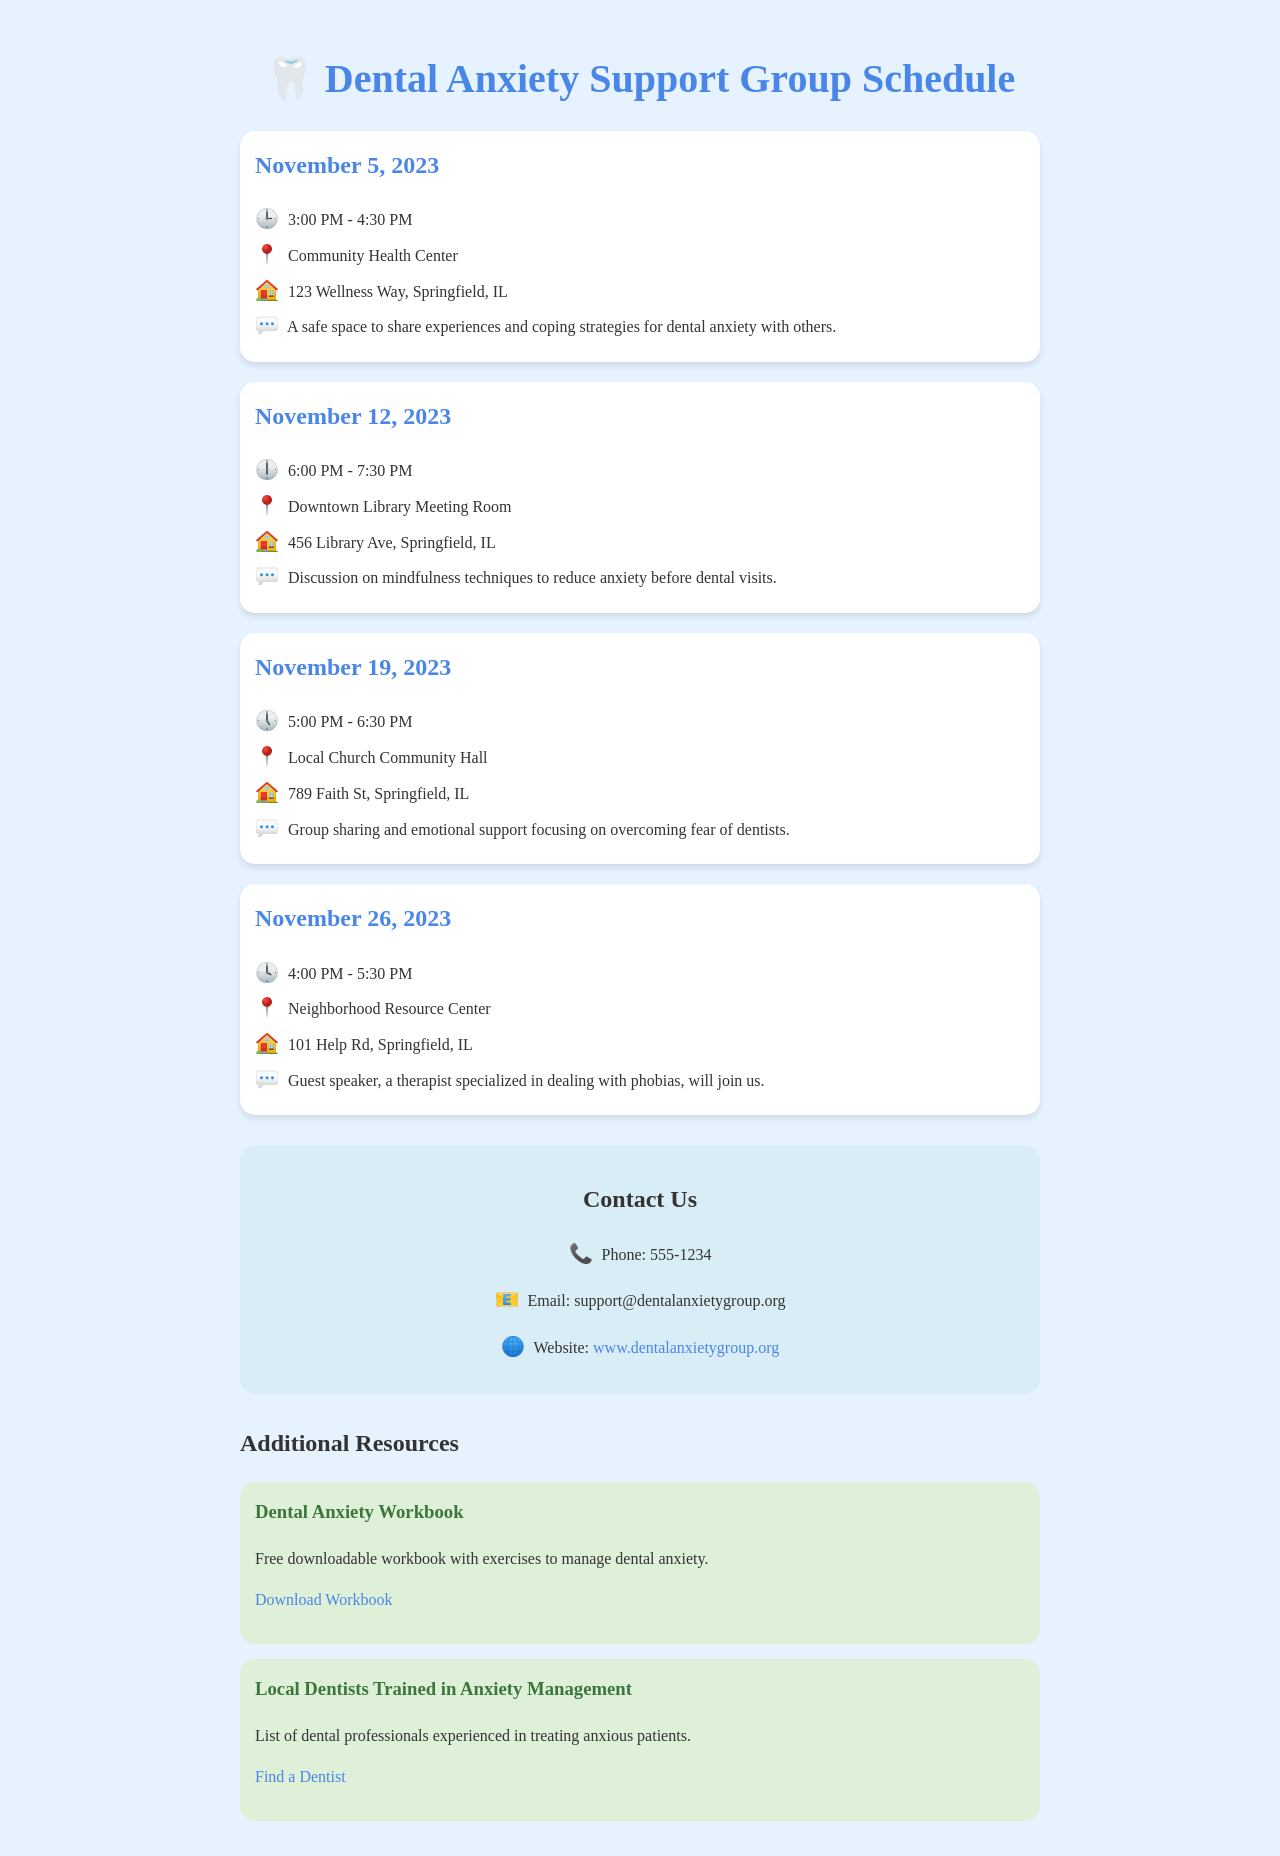What is the date of the first meeting? The first meeting listed in the document is on November 5, 2023.
Answer: November 5, 2023 Where is the second support group meeting held? The second meeting is held at the Downtown Library Meeting Room.
Answer: Downtown Library Meeting Room What is the time of the meeting on November 19, 2023? The meeting on November 19, 2023, is from 5:00 PM to 6:30 PM.
Answer: 5:00 PM - 6:30 PM Who will be the guest speaker at the meeting on November 26, 2023? The document states that a therapist specialized in dealing with phobias will be the guest speaker.
Answer: A therapist specialized in dealing with phobias What is the main focus of the meeting on November 12, 2023? The meeting on November 12, 2023, focuses on mindfulness techniques to reduce anxiety.
Answer: Mindfulness techniques to reduce anxiety What phone number can I call for more information? The phone number provided in the document for more information is 555-1234.
Answer: 555-1234 What website can I visit for additional resources? The document lists the website as www.dentalanxietygroup.org.
Answer: www.dentalanxietygroup.org What type of support is offered in the group meetings? The meetings are a safe space to share experiences and coping strategies for dental anxiety.
Answer: Sharing experiences and coping strategies for dental anxiety 